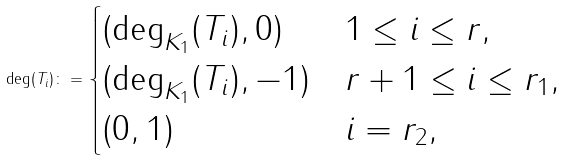Convert formula to latex. <formula><loc_0><loc_0><loc_500><loc_500>\deg ( T _ { i } ) \colon = \begin{cases} ( \deg _ { K _ { 1 } } ( T _ { i } ) , 0 ) & 1 \leq i \leq r , \\ ( \deg _ { K _ { 1 } } ( T _ { i } ) , - 1 ) & r + 1 \leq i \leq r _ { 1 } , \\ ( 0 , 1 ) & i = r _ { 2 } , \end{cases}</formula> 